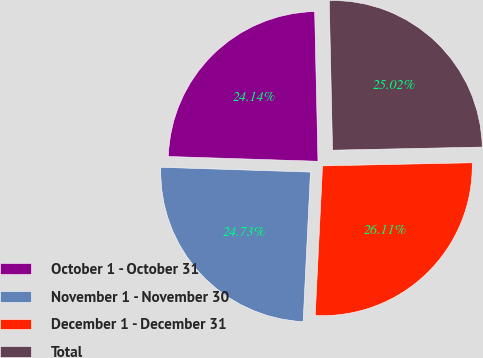Convert chart. <chart><loc_0><loc_0><loc_500><loc_500><pie_chart><fcel>October 1 - October 31<fcel>November 1 - November 30<fcel>December 1 - December 31<fcel>Total<nl><fcel>24.14%<fcel>24.73%<fcel>26.11%<fcel>25.02%<nl></chart> 